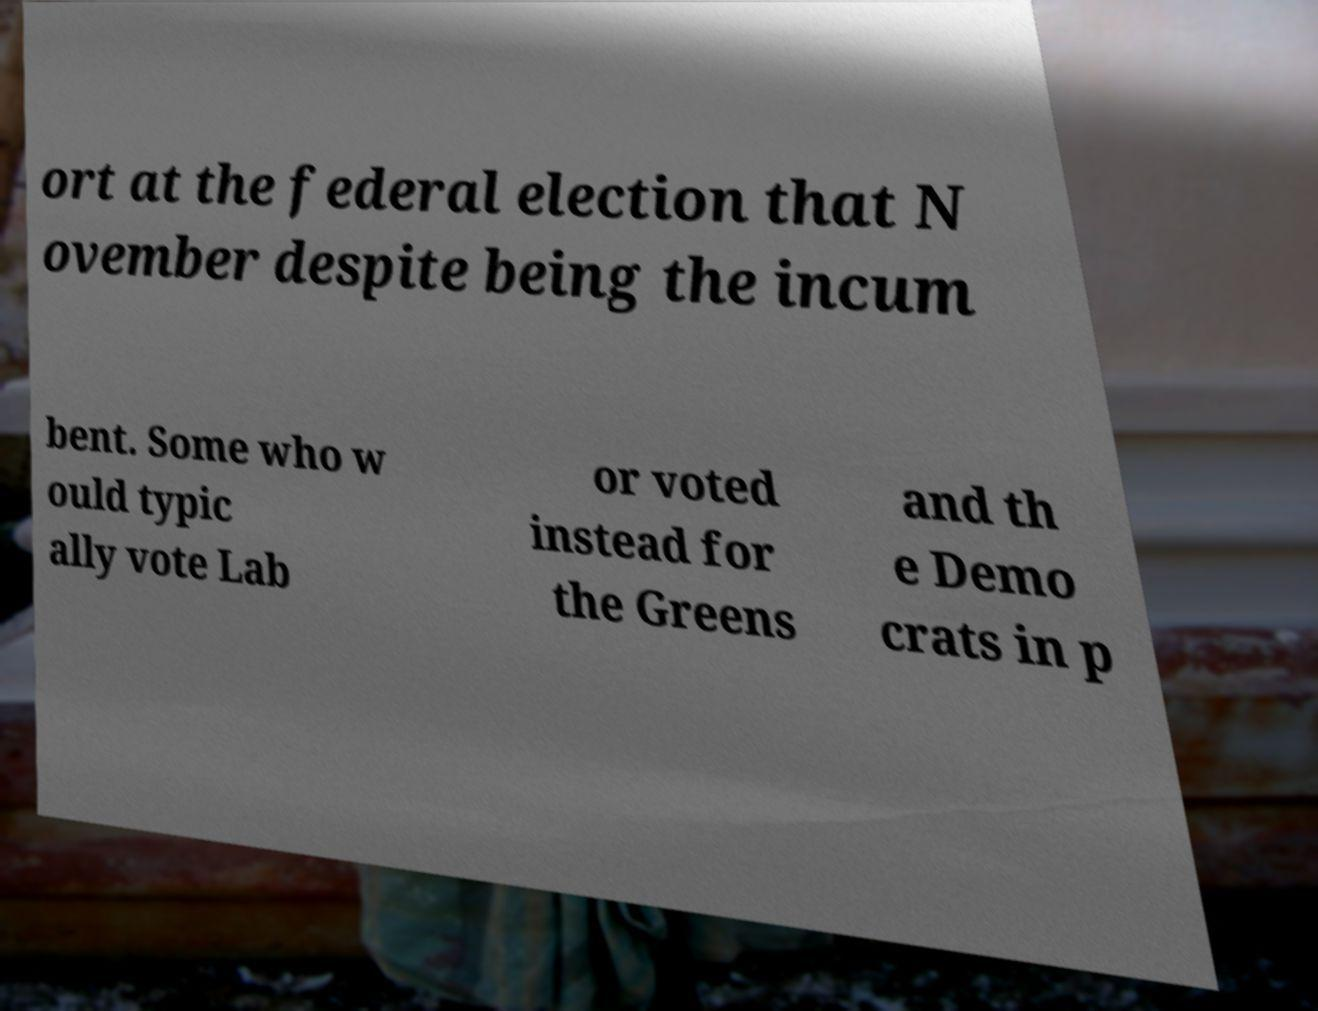Please identify and transcribe the text found in this image. ort at the federal election that N ovember despite being the incum bent. Some who w ould typic ally vote Lab or voted instead for the Greens and th e Demo crats in p 